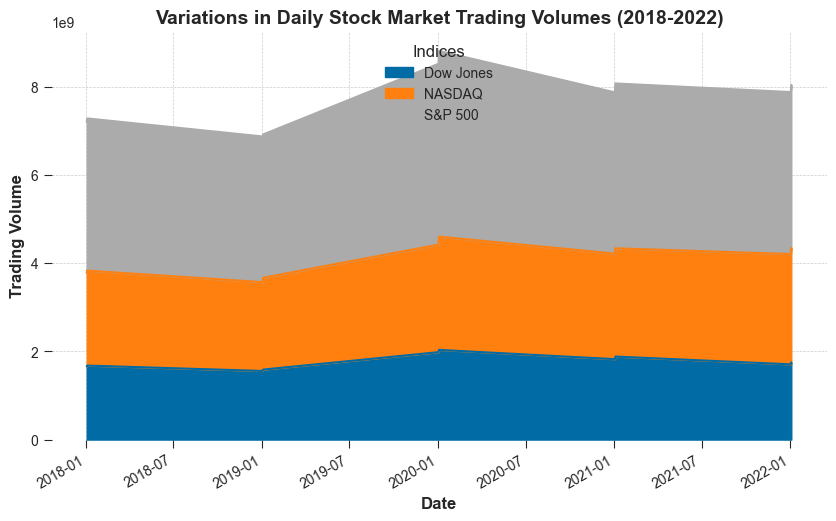Which index had the highest trading volume on January 2, 2020? Identify the lines corresponding to each index on January 2, 2020, and compare the heights to find that S&P 500 had the highest value.
Answer: S&P 500 How did the trading volume of the NASDAQ change from January 2, 2019 to January 2, 2020? Compare the height of the NASDAQ's area on January 2, 2019, and January 2, 2020. The volume increased from ~2014300000 to ~2439200000.
Answer: Increased Which index experienced the greatest increase in trading volume between January 2, 2018 and January 2, 2020? Compare the difference between the heights of the areas for each index on January 2, 2018 and January 2, 2020. The S&P 500 had the highest increase in volume.
Answer: S&P 500 Which date had the lowest combined trading volume among all indices? Assess the combined height of all indices on each date. January 2, 2019, had the lowest combined height compared to other dates.
Answer: January 2, 2019 Compare the trading volumes of Dow Jones on January 2, 2021 and January 2, 2022. Which was higher? Visualize the height of Dow Jones' area on both dates. January 2, 2021, had a higher volume compared to January 2, 2022.
Answer: January 2, 2021 What is the overall trend of trading volumes for the S&P 500 from 2018 to 2022? Observe the general pattern in the height of the S&P 500's area over the years on the x-axis. The trend shows an increase in trading volume over the period.
Answer: Increasing Calculate the sum of trading volumes for all indices on January 2, 2020. Add the heights of all indices' areas on January 2, 2020: S&P 500 ~4102300000, NASDAQ ~2439200000, Dow Jones ~1982300000. The total is ~8523800000.
Answer: ~8523800000 Did the NASDAQ's trading volume ever exceed that of the Dow Jones from 2018 to 2022? Analyze the overlapping areas for NASDAQ and Dow Jones across the dates to see that NASDAQ's area exceeds Dow Jones on several dates.
Answer: Yes 